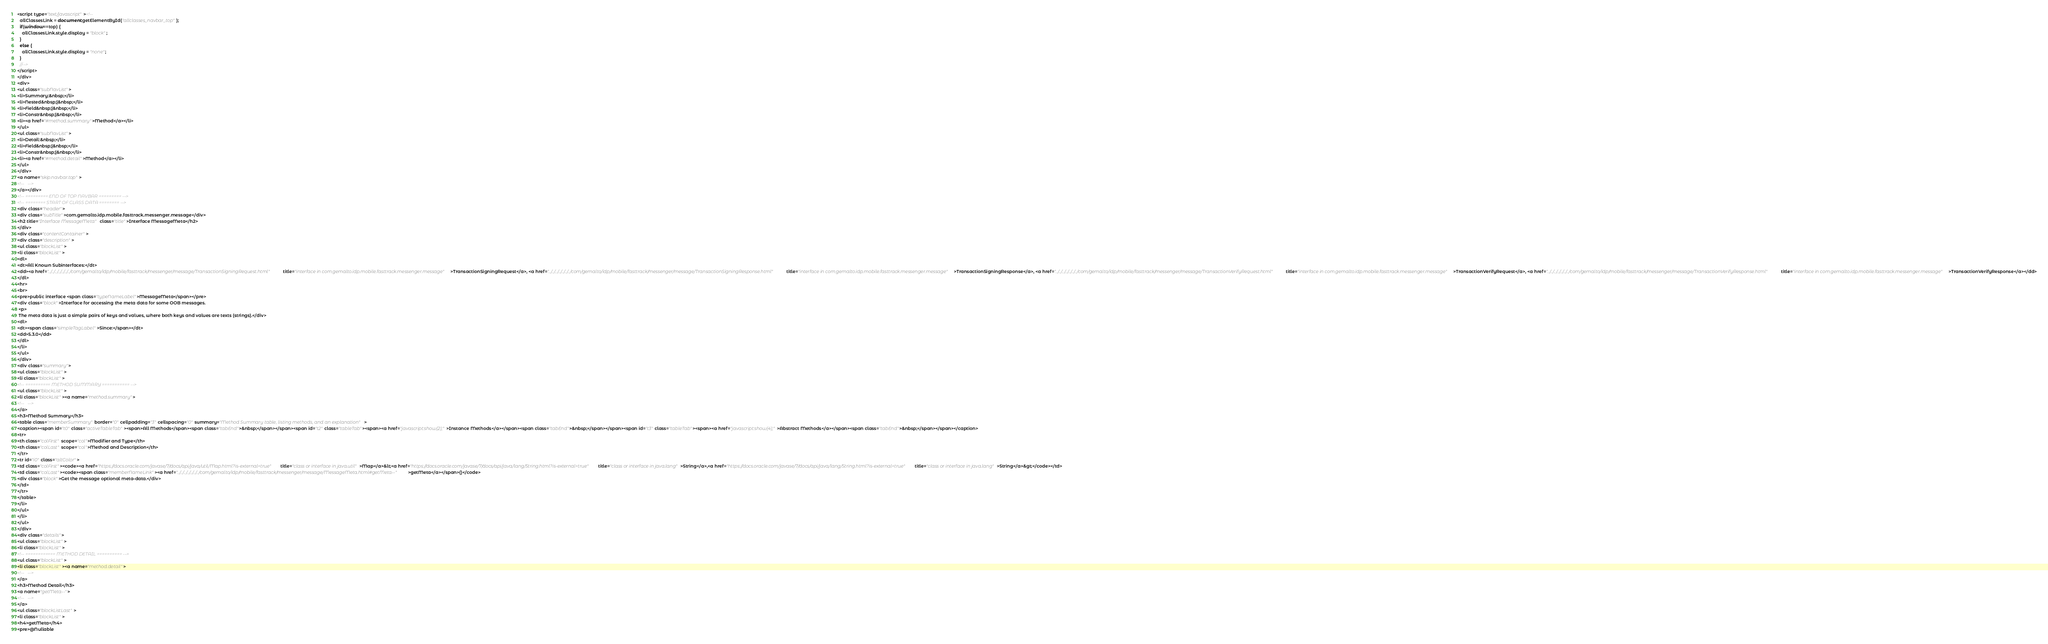<code> <loc_0><loc_0><loc_500><loc_500><_HTML_><script type="text/javascript"><!--
  allClassesLink = document.getElementById("allclasses_navbar_top");
  if(window==top) {
    allClassesLink.style.display = "block";
  }
  else {
    allClassesLink.style.display = "none";
  }
  //-->
</script>
</div>
<div>
<ul class="subNavList">
<li>Summary:&nbsp;</li>
<li>Nested&nbsp;|&nbsp;</li>
<li>Field&nbsp;|&nbsp;</li>
<li>Constr&nbsp;|&nbsp;</li>
<li><a href="#method.summary">Method</a></li>
</ul>
<ul class="subNavList">
<li>Detail:&nbsp;</li>
<li>Field&nbsp;|&nbsp;</li>
<li>Constr&nbsp;|&nbsp;</li>
<li><a href="#method.detail">Method</a></li>
</ul>
</div>
<a name="skip.navbar.top">
<!--   -->
</a></div>
<!-- ========= END OF TOP NAVBAR ========= -->
<!-- ======== START OF CLASS DATA ======== -->
<div class="header">
<div class="subTitle">com.gemalto.idp.mobile.fasttrack.messenger.message</div>
<h2 title="Interface MessageMeta" class="title">Interface MessageMeta</h2>
</div>
<div class="contentContainer">
<div class="description">
<ul class="blockList">
<li class="blockList">
<dl>
<dt>All Known Subinterfaces:</dt>
<dd><a href="../../../../../../../com/gemalto/idp/mobile/fasttrack/messenger/message/TransactionSigningRequest.html" title="interface in com.gemalto.idp.mobile.fasttrack.messenger.message">TransactionSigningRequest</a>, <a href="../../../../../../../com/gemalto/idp/mobile/fasttrack/messenger/message/TransactionSigningResponse.html" title="interface in com.gemalto.idp.mobile.fasttrack.messenger.message">TransactionSigningResponse</a>, <a href="../../../../../../../com/gemalto/idp/mobile/fasttrack/messenger/message/TransactionVerifyRequest.html" title="interface in com.gemalto.idp.mobile.fasttrack.messenger.message">TransactionVerifyRequest</a>, <a href="../../../../../../../com/gemalto/idp/mobile/fasttrack/messenger/message/TransactionVerifyResponse.html" title="interface in com.gemalto.idp.mobile.fasttrack.messenger.message">TransactionVerifyResponse</a></dd>
</dl>
<hr>
<br>
<pre>public interface <span class="typeNameLabel">MessageMeta</span></pre>
<div class="block">Interface for accessing the meta data for some OOB messages.
 <p>
 The meta data is just a simple pairs of keys and values, where both keys and values are texts (strings).</div>
<dl>
<dt><span class="simpleTagLabel">Since:</span></dt>
<dd>5.3.0</dd>
</dl>
</li>
</ul>
</div>
<div class="summary">
<ul class="blockList">
<li class="blockList">
<!-- ========== METHOD SUMMARY =========== -->
<ul class="blockList">
<li class="blockList"><a name="method.summary">
<!--   -->
</a>
<h3>Method Summary</h3>
<table class="memberSummary" border="0" cellpadding="3" cellspacing="0" summary="Method Summary table, listing methods, and an explanation">
<caption><span id="t0" class="activeTableTab"><span>All Methods</span><span class="tabEnd">&nbsp;</span></span><span id="t2" class="tableTab"><span><a href="javascript:show(2);">Instance Methods</a></span><span class="tabEnd">&nbsp;</span></span><span id="t3" class="tableTab"><span><a href="javascript:show(4);">Abstract Methods</a></span><span class="tabEnd">&nbsp;</span></span></caption>
<tr>
<th class="colFirst" scope="col">Modifier and Type</th>
<th class="colLast" scope="col">Method and Description</th>
</tr>
<tr id="i0" class="altColor">
<td class="colFirst"><code><a href="https://docs.oracle.com/javase/7/docs/api/java/util/Map.html?is-external=true" title="class or interface in java.util">Map</a>&lt;<a href="https://docs.oracle.com/javase/7/docs/api/java/lang/String.html?is-external=true" title="class or interface in java.lang">String</a>,<a href="https://docs.oracle.com/javase/7/docs/api/java/lang/String.html?is-external=true" title="class or interface in java.lang">String</a>&gt;</code></td>
<td class="colLast"><code><span class="memberNameLink"><a href="../../../../../../../com/gemalto/idp/mobile/fasttrack/messenger/message/MessageMeta.html#getMeta--">getMeta</a></span>()</code>
<div class="block">Get the message optional meta-data.</div>
</td>
</tr>
</table>
</li>
</ul>
</li>
</ul>
</div>
<div class="details">
<ul class="blockList">
<li class="blockList">
<!-- ============ METHOD DETAIL ========== -->
<ul class="blockList">
<li class="blockList"><a name="method.detail">
<!--   -->
</a>
<h3>Method Detail</h3>
<a name="getMeta--">
<!--   -->
</a>
<ul class="blockListLast">
<li class="blockList">
<h4>getMeta</h4>
<pre>@Nullable</code> 